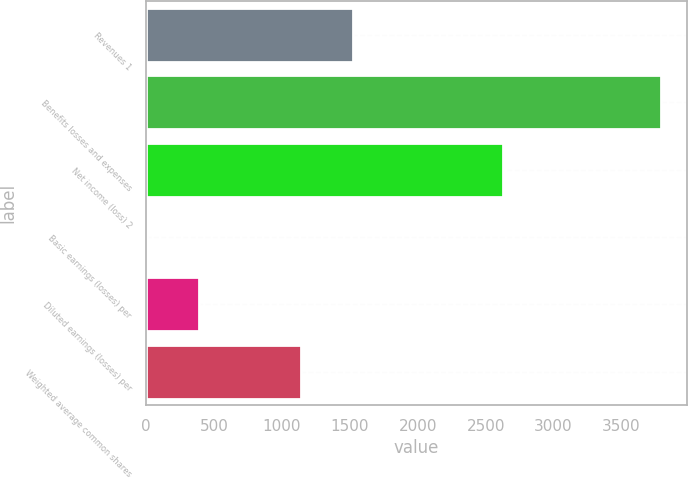Convert chart to OTSL. <chart><loc_0><loc_0><loc_500><loc_500><bar_chart><fcel>Revenues 1<fcel>Benefits losses and expenses<fcel>Net income (loss) 2<fcel>Basic earnings (losses) per<fcel>Diluted earnings (losses) per<fcel>Weighted average common shares<nl><fcel>1521.26<fcel>3790<fcel>2631<fcel>8.74<fcel>386.87<fcel>1143.13<nl></chart> 